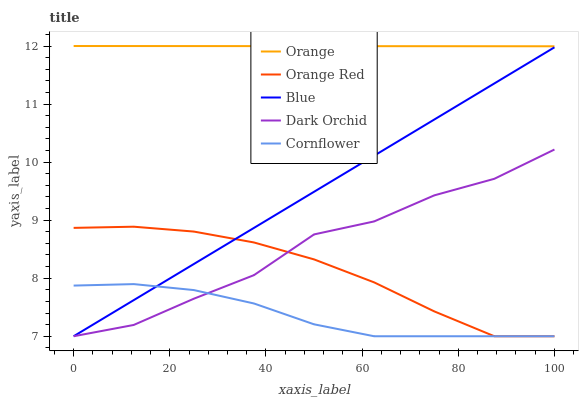Does Cornflower have the minimum area under the curve?
Answer yes or no. Yes. Does Orange have the maximum area under the curve?
Answer yes or no. Yes. Does Blue have the minimum area under the curve?
Answer yes or no. No. Does Blue have the maximum area under the curve?
Answer yes or no. No. Is Blue the smoothest?
Answer yes or no. Yes. Is Dark Orchid the roughest?
Answer yes or no. Yes. Is Orange Red the smoothest?
Answer yes or no. No. Is Orange Red the roughest?
Answer yes or no. No. Does Blue have the lowest value?
Answer yes or no. Yes. Does Orange have the highest value?
Answer yes or no. Yes. Does Blue have the highest value?
Answer yes or no. No. Is Cornflower less than Orange?
Answer yes or no. Yes. Is Orange greater than Dark Orchid?
Answer yes or no. Yes. Does Orange Red intersect Dark Orchid?
Answer yes or no. Yes. Is Orange Red less than Dark Orchid?
Answer yes or no. No. Is Orange Red greater than Dark Orchid?
Answer yes or no. No. Does Cornflower intersect Orange?
Answer yes or no. No. 